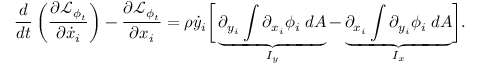Convert formula to latex. <formula><loc_0><loc_0><loc_500><loc_500>\frac { d } { d t } \left ( \frac { \partial \mathcal { L } _ { \phi _ { t } } } { \partial \dot { x } _ { i } } \right ) - \frac { \partial \mathcal { L } _ { \phi _ { t } } } { \partial x _ { i } } = \rho \dot { y } _ { i } \left [ \underbrace { \partial _ { y _ { i } } \int \partial _ { x _ { i } } \phi _ { i } \, d A } _ { I _ { y } } - \underbrace { \partial _ { x _ { i } } \int \partial _ { y _ { i } } \phi _ { i } \, d A } _ { I _ { x } } \right ] .</formula> 